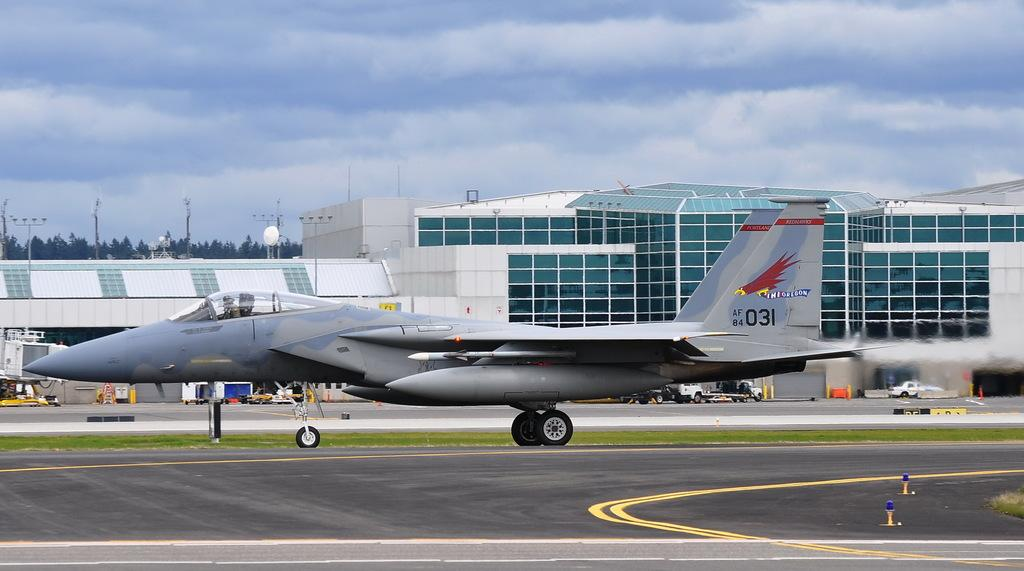<image>
Give a short and clear explanation of the subsequent image. A fighter jet is taxiing on a runway with the tail number 031. 